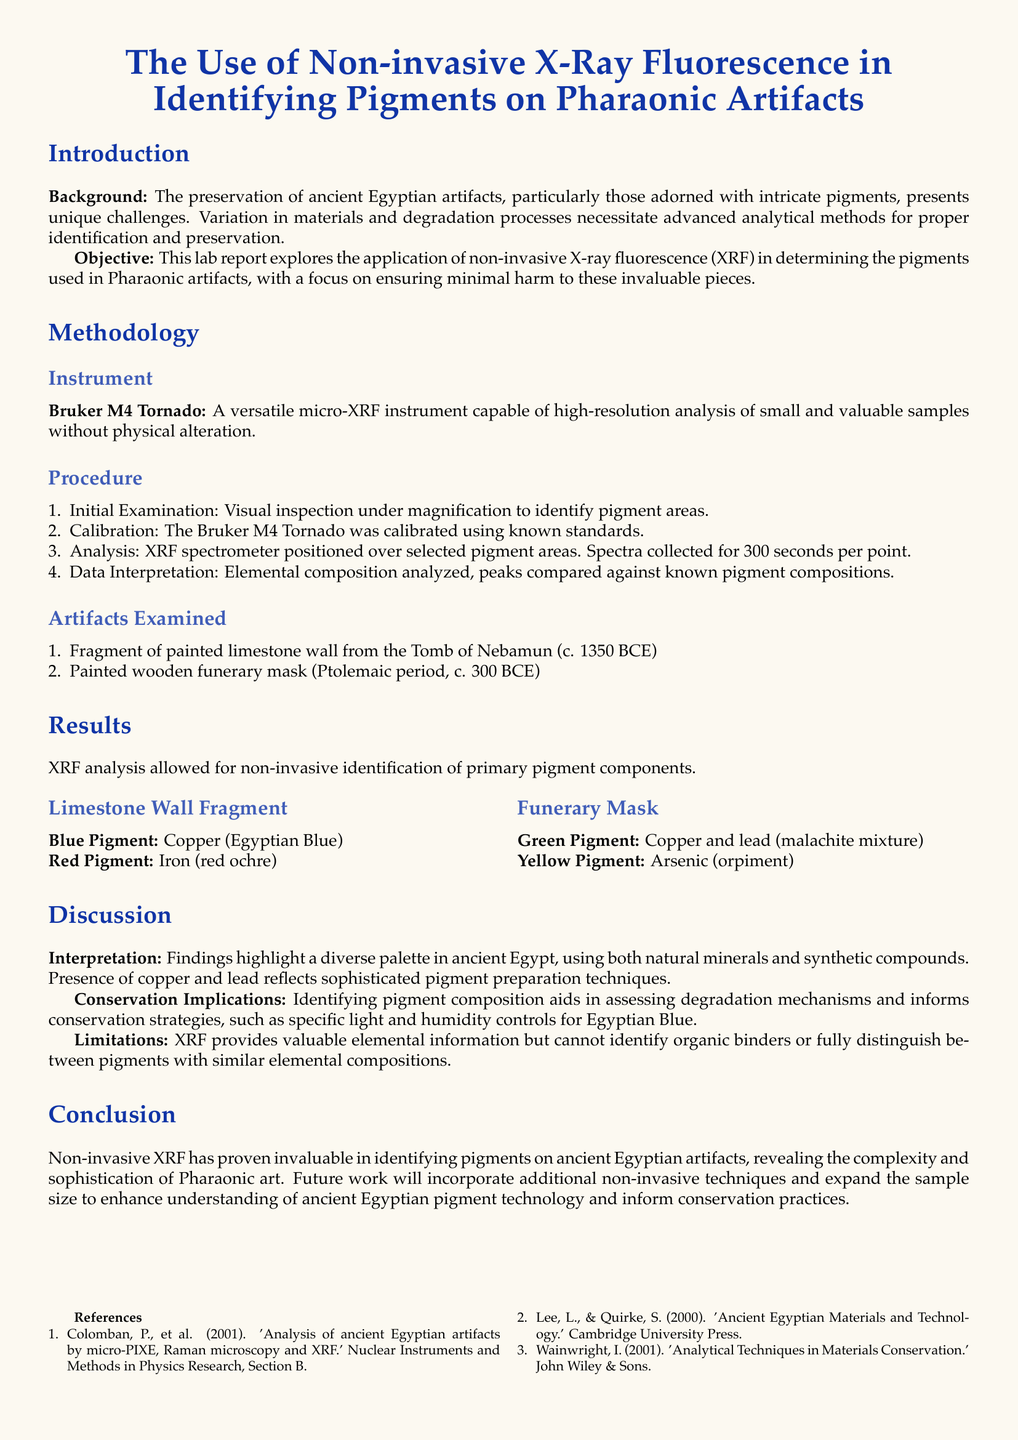What is the name of the instrument used in the study? The document specifies the use of the Bruker M4 Tornado for the analysis of pigments on artifacts.
Answer: Bruker M4 Tornado What period does the painted wooden funerary mask belong to? The document mentions that the funerary mask is from the Ptolemaic period, around 300 BCE.
Answer: Ptolemaic period What is the primary blue pigment identified in the limestone wall fragment? The analysis revealed that the blue pigment on the limestone wall fragment is Copper, specifically Egyptian Blue.
Answer: Copper (Egyptian Blue) How long was the XRF spectra collected for each point? According to the document, the spectra were collected for 300 seconds per point during the analysis.
Answer: 300 seconds What are the two pigments found on the funerary mask? The findings for the funerary mask include a green pigment (Copper and lead) and a yellow pigment (Arsenic).
Answer: Copper and lead; Arsenic What does XRF stand for? The introduction specifies that X-Ray Fluorescence is commonly abbreviated as XRF.
Answer: X-Ray Fluorescence What is one limitation of XRF mentioned in the report? The report states that XRF cannot identify organic binders which limits its capability in certain analyses.
Answer: Cannot identify organic binders What does the conservation implication of identifying pigment composition entail? The document discusses that identifying pigments aids in assessing degradation mechanisms and informs conservation strategies.
Answer: Assessing degradation mechanisms 